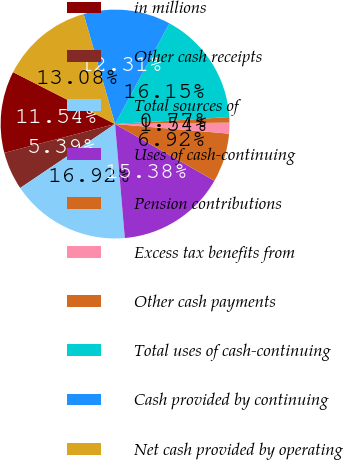Convert chart to OTSL. <chart><loc_0><loc_0><loc_500><loc_500><pie_chart><fcel>in millions<fcel>Other cash receipts<fcel>Total sources of<fcel>Uses of cash-continuing<fcel>Pension contributions<fcel>Excess tax benefits from<fcel>Other cash payments<fcel>Total uses of cash-continuing<fcel>Cash provided by continuing<fcel>Net cash provided by operating<nl><fcel>11.54%<fcel>5.39%<fcel>16.92%<fcel>15.38%<fcel>6.92%<fcel>1.54%<fcel>0.77%<fcel>16.15%<fcel>12.31%<fcel>13.08%<nl></chart> 